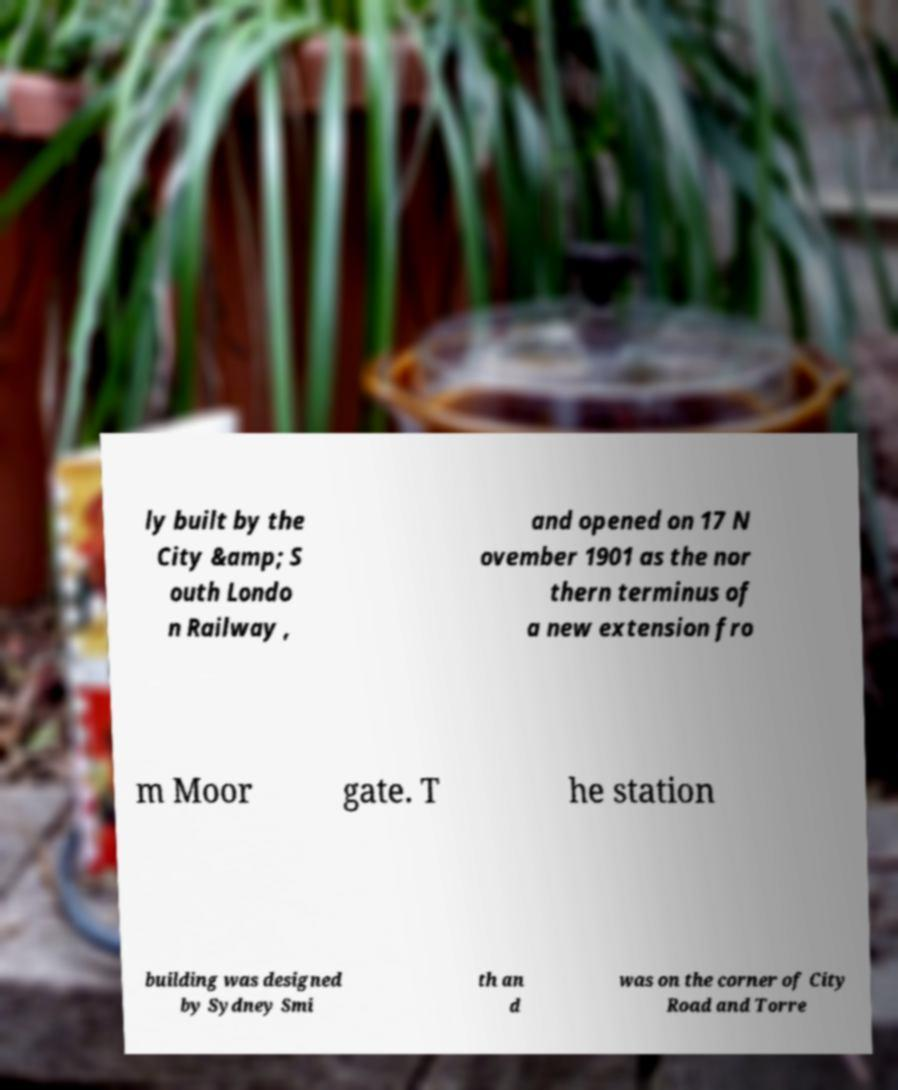Could you assist in decoding the text presented in this image and type it out clearly? ly built by the City &amp; S outh Londo n Railway , and opened on 17 N ovember 1901 as the nor thern terminus of a new extension fro m Moor gate. T he station building was designed by Sydney Smi th an d was on the corner of City Road and Torre 